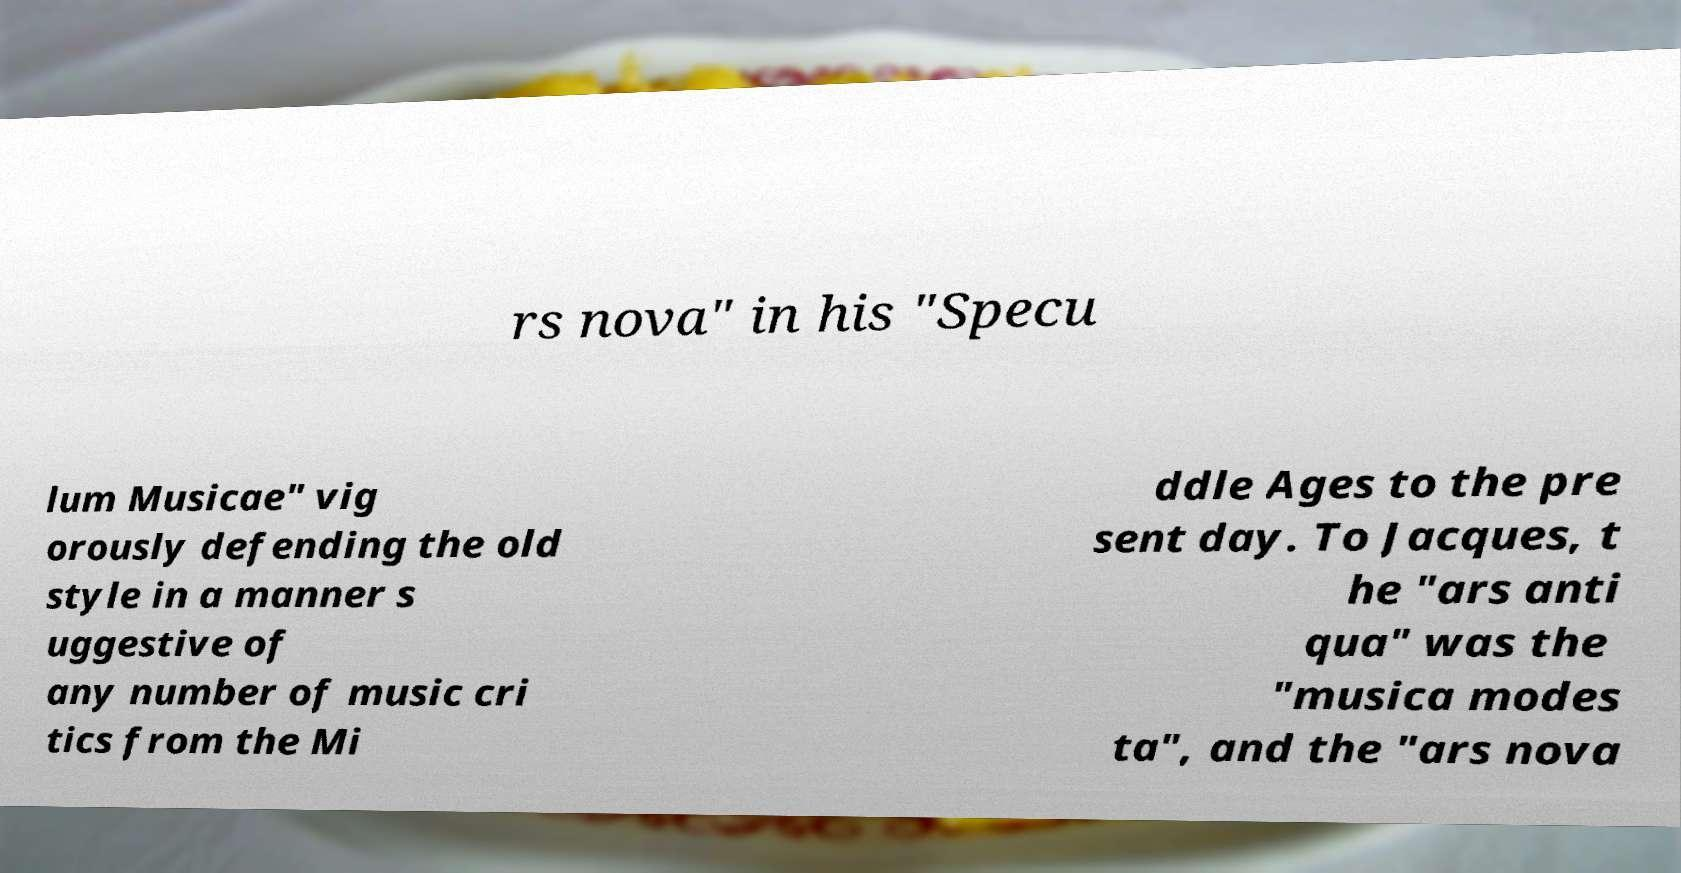Please identify and transcribe the text found in this image. rs nova" in his "Specu lum Musicae" vig orously defending the old style in a manner s uggestive of any number of music cri tics from the Mi ddle Ages to the pre sent day. To Jacques, t he "ars anti qua" was the "musica modes ta", and the "ars nova 